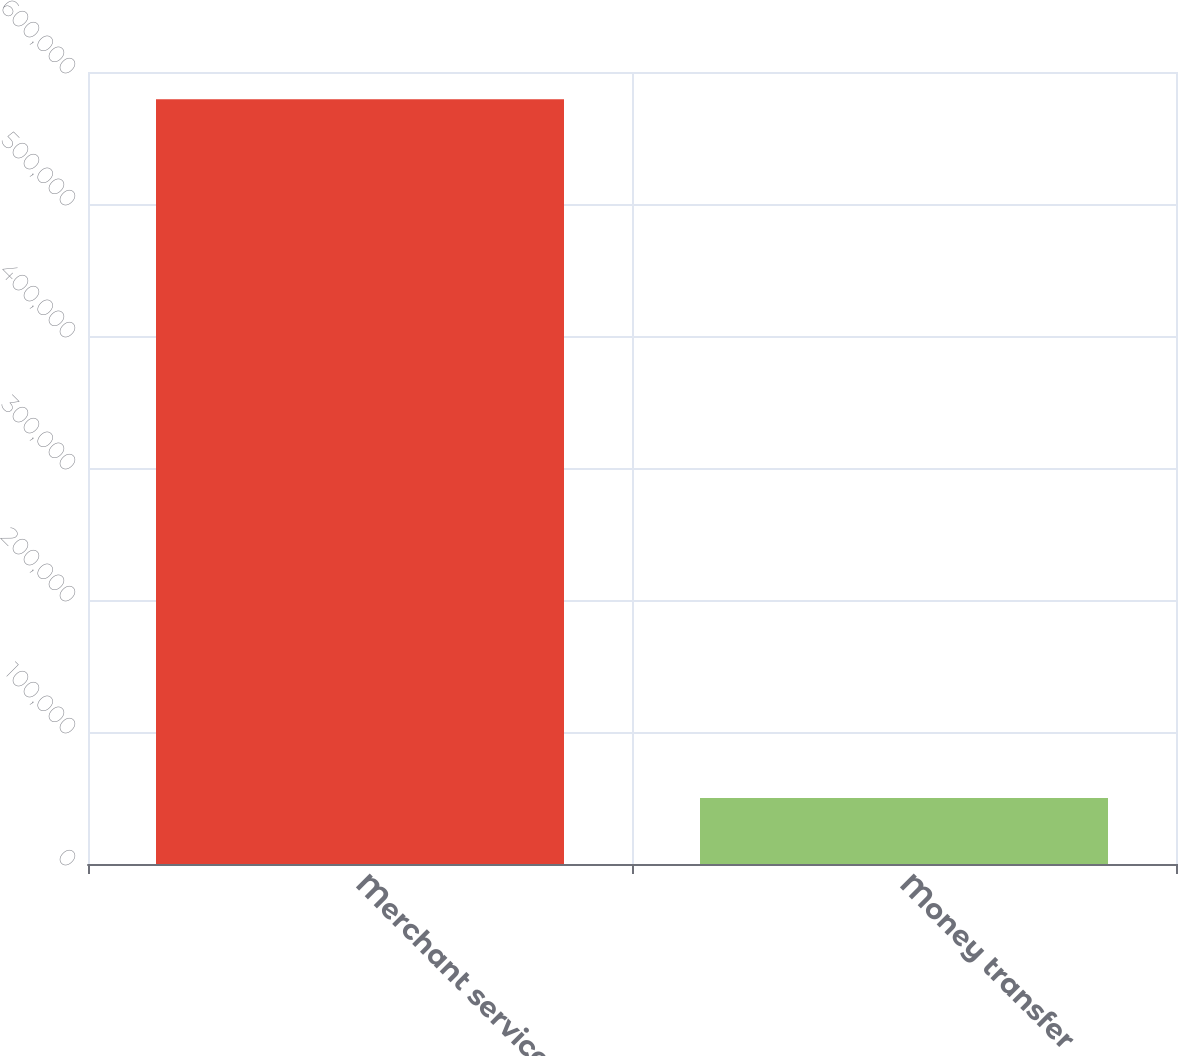<chart> <loc_0><loc_0><loc_500><loc_500><bar_chart><fcel>Merchant services<fcel>Money transfer<nl><fcel>579387<fcel>49933<nl></chart> 